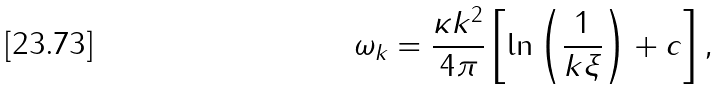<formula> <loc_0><loc_0><loc_500><loc_500>\omega _ { k } = \frac { \kappa k ^ { 2 } } { 4 \pi } \left [ \ln \left ( \frac { 1 } { k \xi } \right ) + c \right ] ,</formula> 